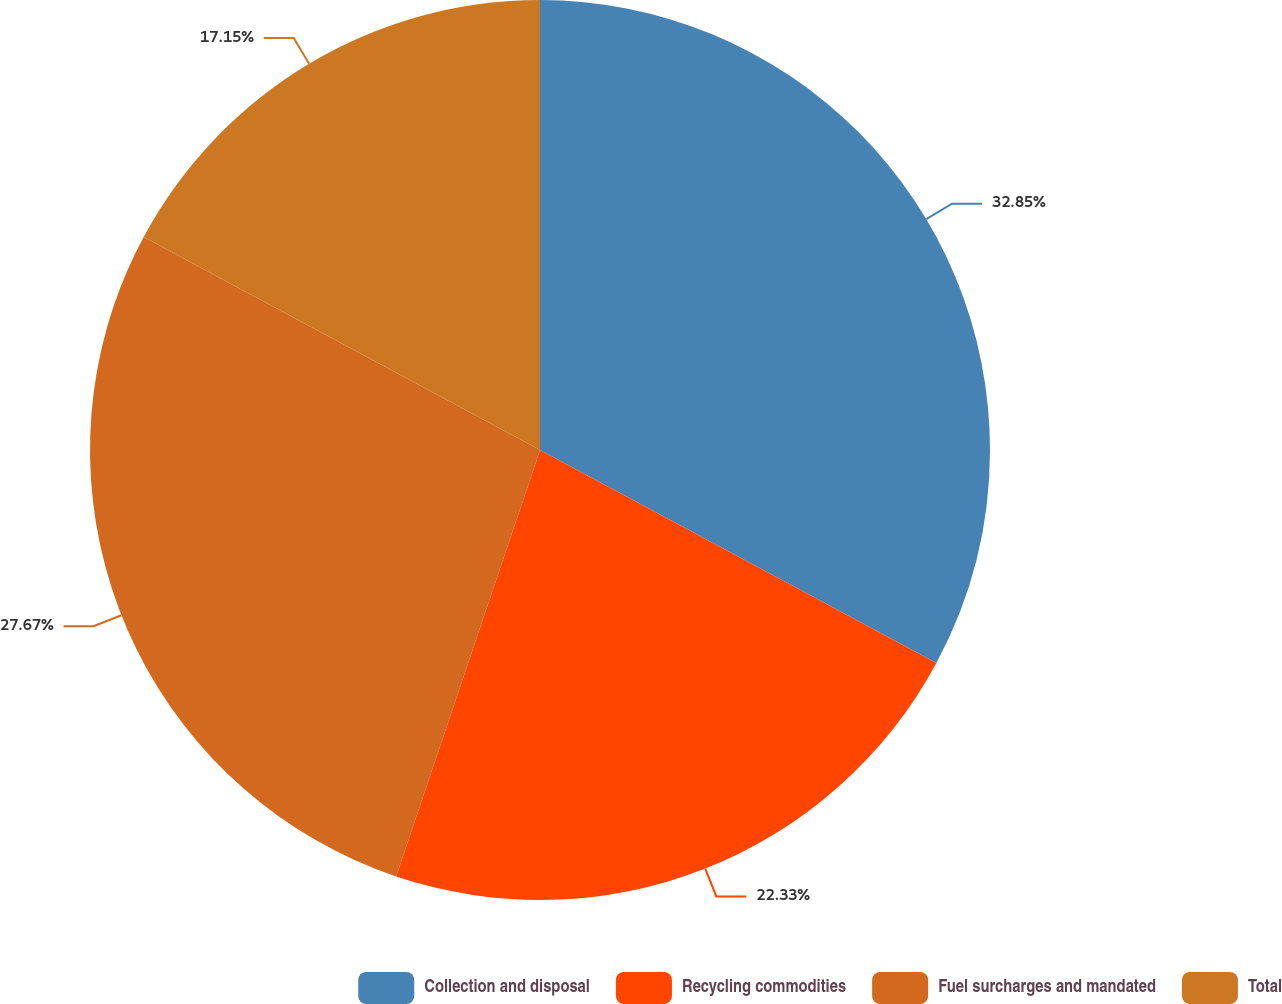<chart> <loc_0><loc_0><loc_500><loc_500><pie_chart><fcel>Collection and disposal<fcel>Recycling commodities<fcel>Fuel surcharges and mandated<fcel>Total<nl><fcel>32.85%<fcel>22.33%<fcel>27.67%<fcel>17.15%<nl></chart> 